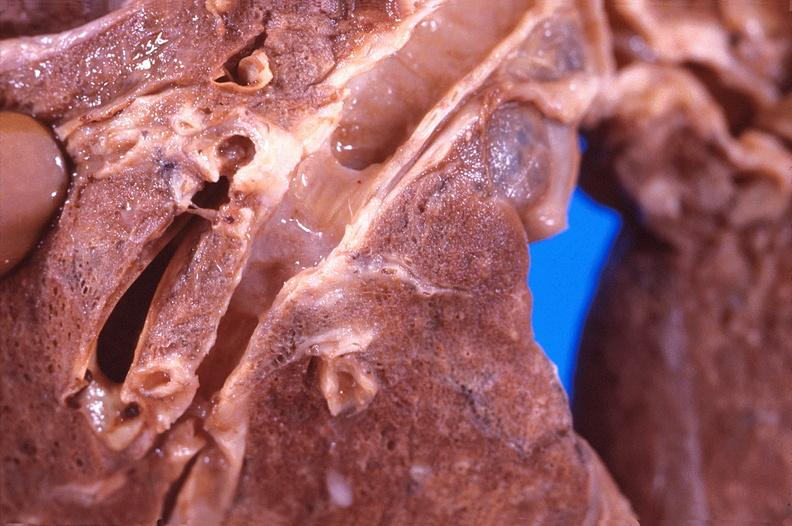s respiratory present?
Answer the question using a single word or phrase. Yes 